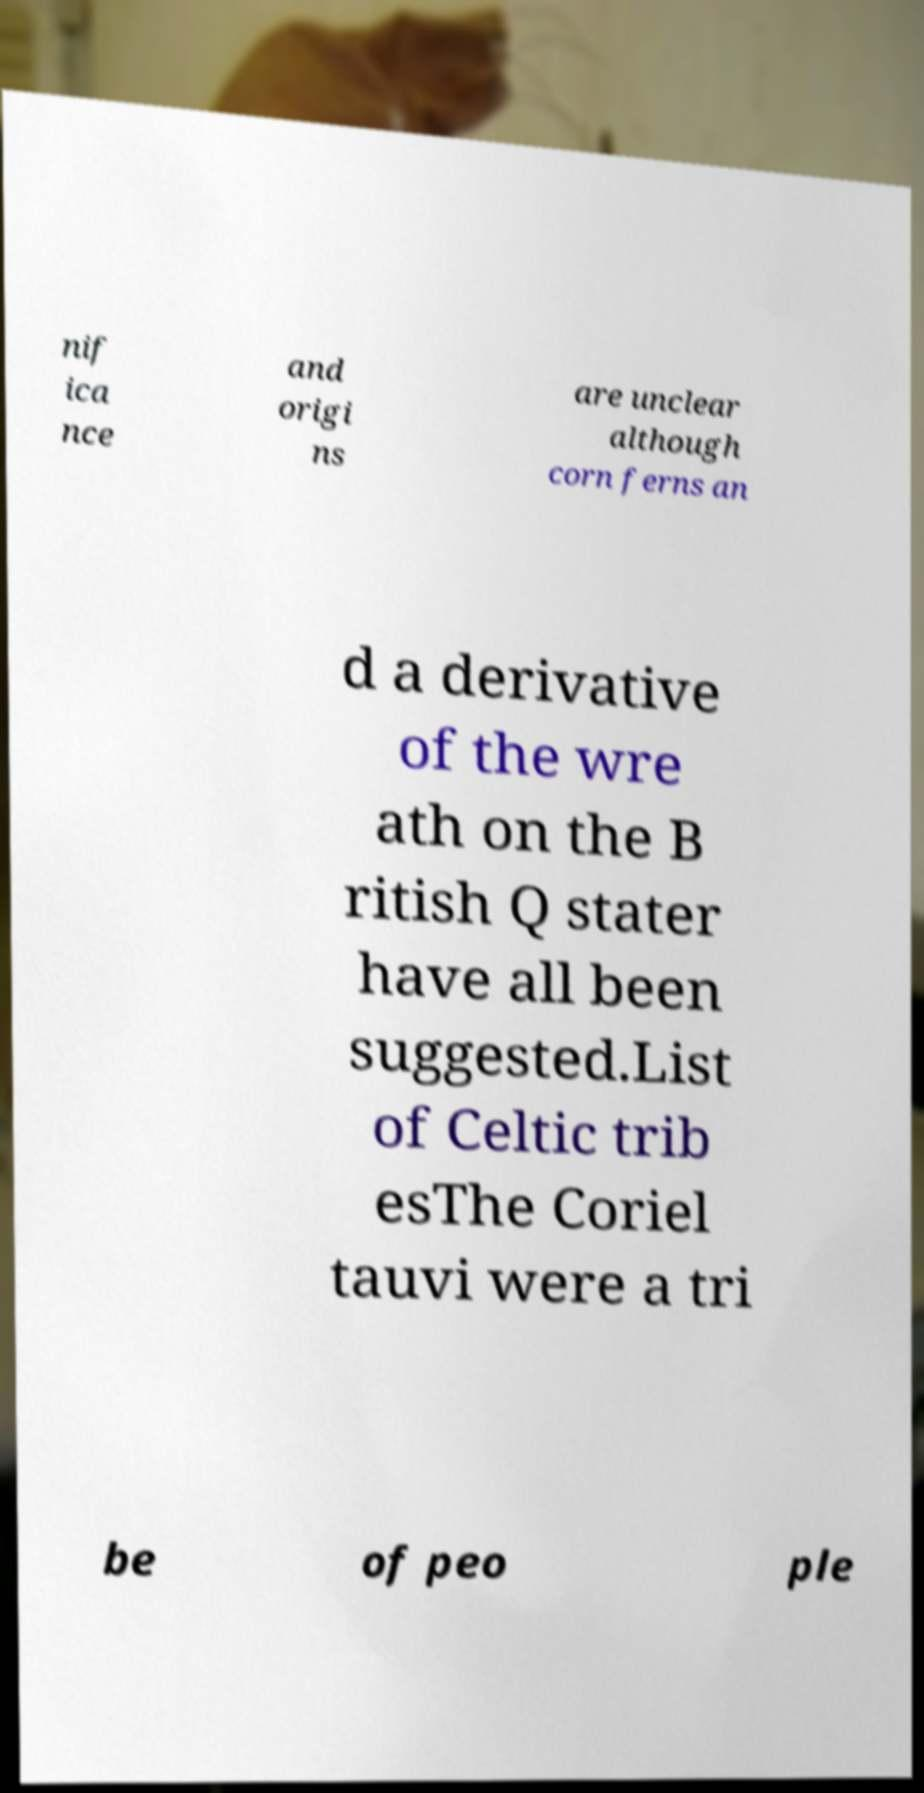Please read and relay the text visible in this image. What does it say? nif ica nce and origi ns are unclear although corn ferns an d a derivative of the wre ath on the B ritish Q stater have all been suggested.List of Celtic trib esThe Coriel tauvi were a tri be of peo ple 